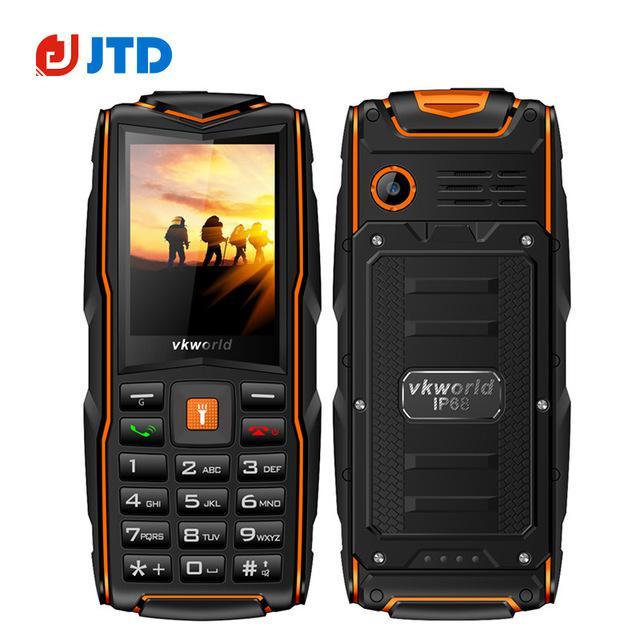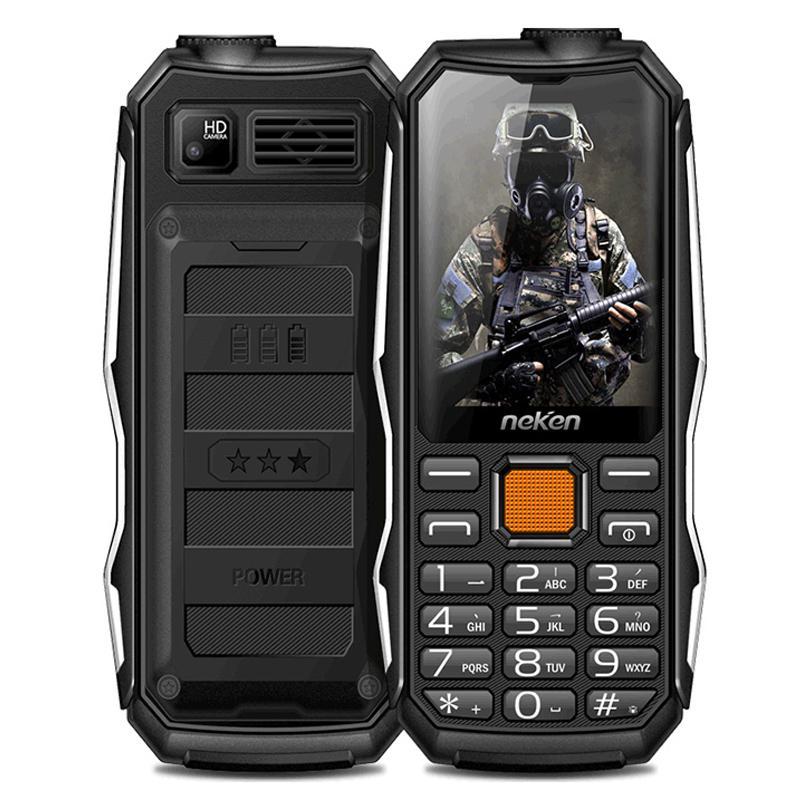The first image is the image on the left, the second image is the image on the right. For the images displayed, is the sentence "One image features a grenade-look flip phone with a round 'pin' on its side, and the phone is shown flipped open in at least a forward and a side view." factually correct? Answer yes or no. No. The first image is the image on the left, the second image is the image on the right. For the images displayed, is the sentence "One of the phones shows an image of four people in a sunset." factually correct? Answer yes or no. Yes. 